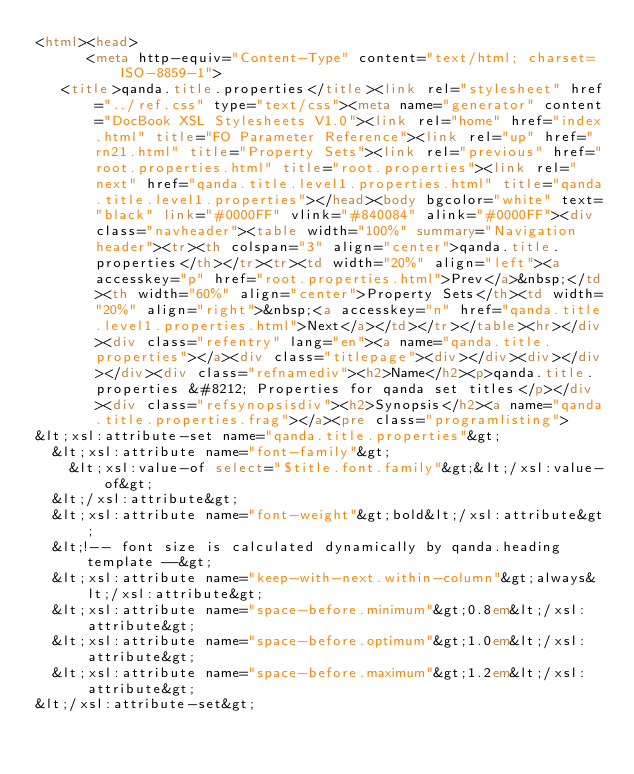<code> <loc_0><loc_0><loc_500><loc_500><_HTML_><html><head>
      <meta http-equiv="Content-Type" content="text/html; charset=ISO-8859-1">
   <title>qanda.title.properties</title><link rel="stylesheet" href="../ref.css" type="text/css"><meta name="generator" content="DocBook XSL Stylesheets V1.0"><link rel="home" href="index.html" title="FO Parameter Reference"><link rel="up" href="rn21.html" title="Property Sets"><link rel="previous" href="root.properties.html" title="root.properties"><link rel="next" href="qanda.title.level1.properties.html" title="qanda.title.level1.properties"></head><body bgcolor="white" text="black" link="#0000FF" vlink="#840084" alink="#0000FF"><div class="navheader"><table width="100%" summary="Navigation header"><tr><th colspan="3" align="center">qanda.title.properties</th></tr><tr><td width="20%" align="left"><a accesskey="p" href="root.properties.html">Prev</a>&nbsp;</td><th width="60%" align="center">Property Sets</th><td width="20%" align="right">&nbsp;<a accesskey="n" href="qanda.title.level1.properties.html">Next</a></td></tr></table><hr></div><div class="refentry" lang="en"><a name="qanda.title.properties"></a><div class="titlepage"><div></div><div></div></div><div class="refnamediv"><h2>Name</h2><p>qanda.title.properties &#8212; Properties for qanda set titles</p></div><div class="refsynopsisdiv"><h2>Synopsis</h2><a name="qanda.title.properties.frag"></a><pre class="programlisting">
&lt;xsl:attribute-set name="qanda.title.properties"&gt;
  &lt;xsl:attribute name="font-family"&gt;
    &lt;xsl:value-of select="$title.font.family"&gt;&lt;/xsl:value-of&gt;
  &lt;/xsl:attribute&gt;
  &lt;xsl:attribute name="font-weight"&gt;bold&lt;/xsl:attribute&gt;
  &lt;!-- font size is calculated dynamically by qanda.heading template --&gt;
  &lt;xsl:attribute name="keep-with-next.within-column"&gt;always&lt;/xsl:attribute&gt;
  &lt;xsl:attribute name="space-before.minimum"&gt;0.8em&lt;/xsl:attribute&gt;
  &lt;xsl:attribute name="space-before.optimum"&gt;1.0em&lt;/xsl:attribute&gt;
  &lt;xsl:attribute name="space-before.maximum"&gt;1.2em&lt;/xsl:attribute&gt;
&lt;/xsl:attribute-set&gt;</code> 